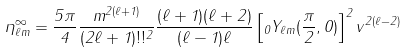Convert formula to latex. <formula><loc_0><loc_0><loc_500><loc_500>\eta ^ { \infty } _ { \ell m } = \frac { 5 \pi } { 4 } \frac { m ^ { 2 ( \ell + 1 ) } } { ( 2 \ell + 1 ) ! ! ^ { 2 } } \frac { ( \ell + 1 ) ( \ell + 2 ) } { ( \ell - 1 ) \ell } \left [ _ { 0 } Y _ { \ell m } ( { \frac { \pi } { 2 } } , 0 ) \right ] ^ { 2 } v ^ { 2 ( \ell - 2 ) }</formula> 